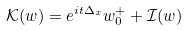<formula> <loc_0><loc_0><loc_500><loc_500>\mathcal { K } ( w ) = e ^ { i t \Delta _ { x } } w _ { 0 } ^ { + } + \mathcal { I } ( w )</formula> 